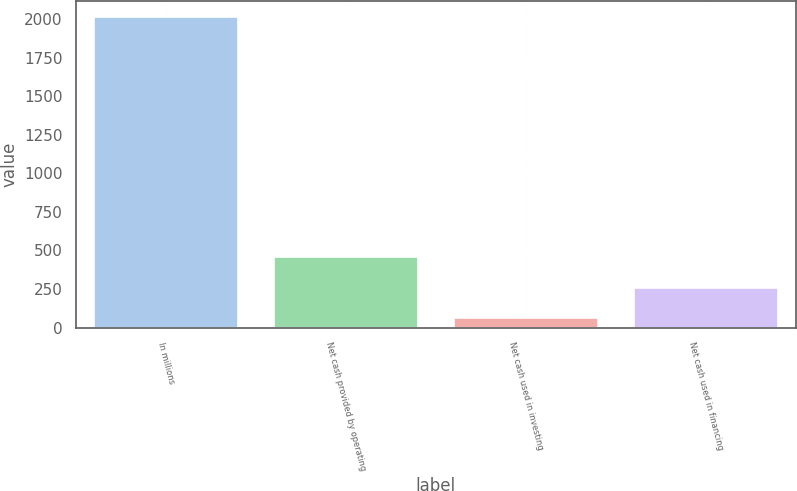<chart> <loc_0><loc_0><loc_500><loc_500><bar_chart><fcel>In millions<fcel>Net cash provided by operating<fcel>Net cash used in investing<fcel>Net cash used in financing<nl><fcel>2016<fcel>454.4<fcel>64<fcel>259.2<nl></chart> 